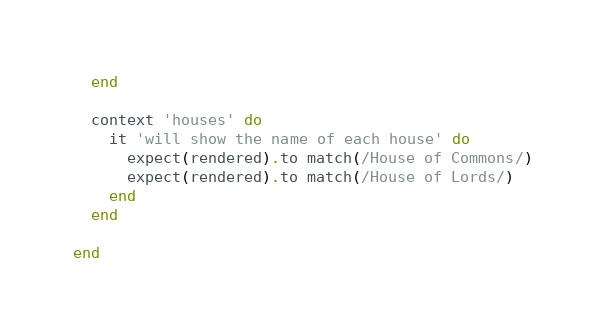Convert code to text. <code><loc_0><loc_0><loc_500><loc_500><_Ruby_>  end

  context 'houses' do
    it 'will show the name of each house' do
      expect(rendered).to match(/House of Commons/)
      expect(rendered).to match(/House of Lords/)
    end
  end

end
</code> 